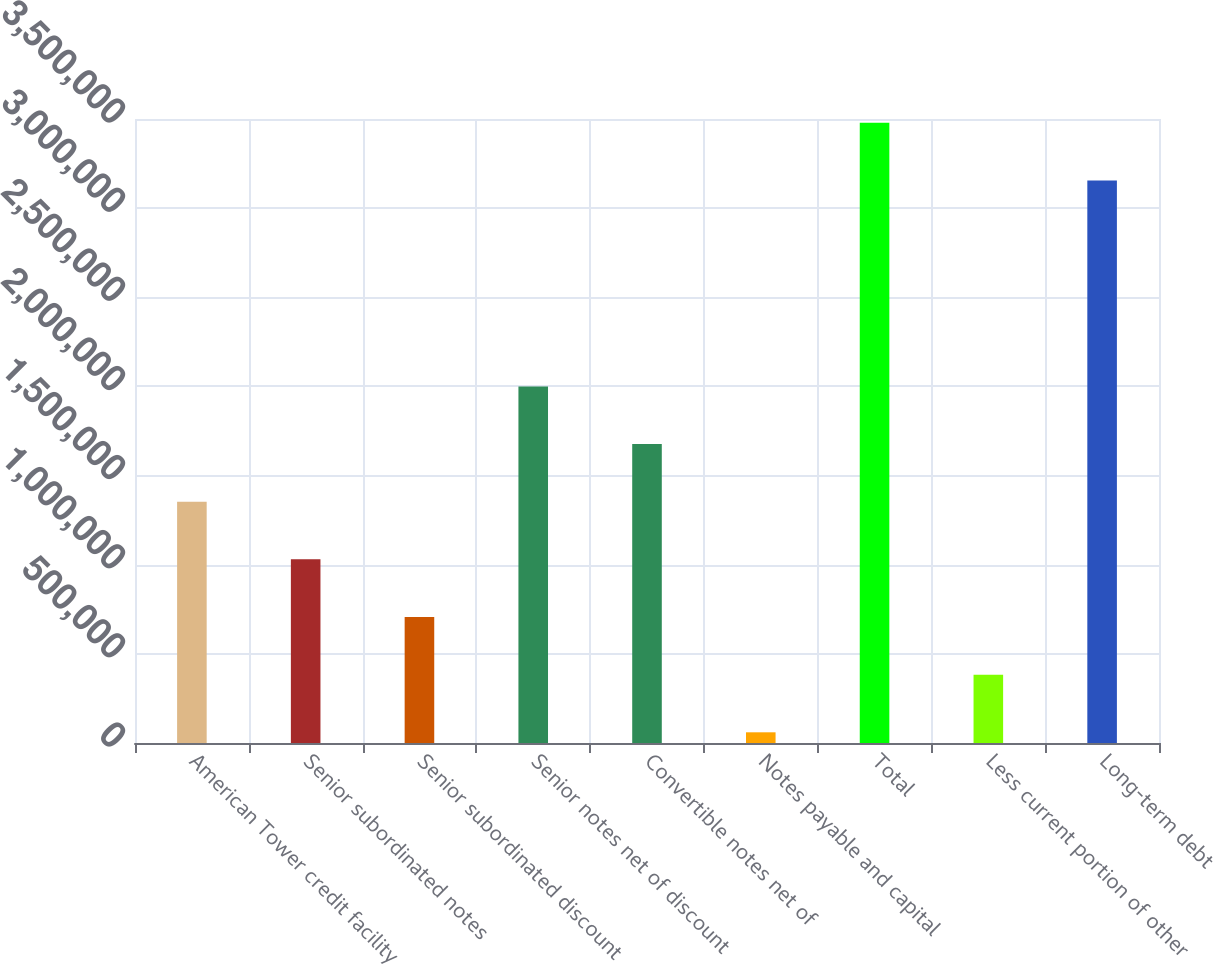Convert chart to OTSL. <chart><loc_0><loc_0><loc_500><loc_500><bar_chart><fcel>American Tower credit facility<fcel>Senior subordinated notes<fcel>Senior subordinated discount<fcel>Senior notes net of discount<fcel>Convertible notes net of<fcel>Notes payable and capital<fcel>Total<fcel>Less current portion of other<fcel>Long-term debt<nl><fcel>1.35344e+06<fcel>1.03007e+06<fcel>706712<fcel>2.00016e+06<fcel>1.6768e+06<fcel>59986<fcel>3.47859e+06<fcel>383349<fcel>3.15523e+06<nl></chart> 